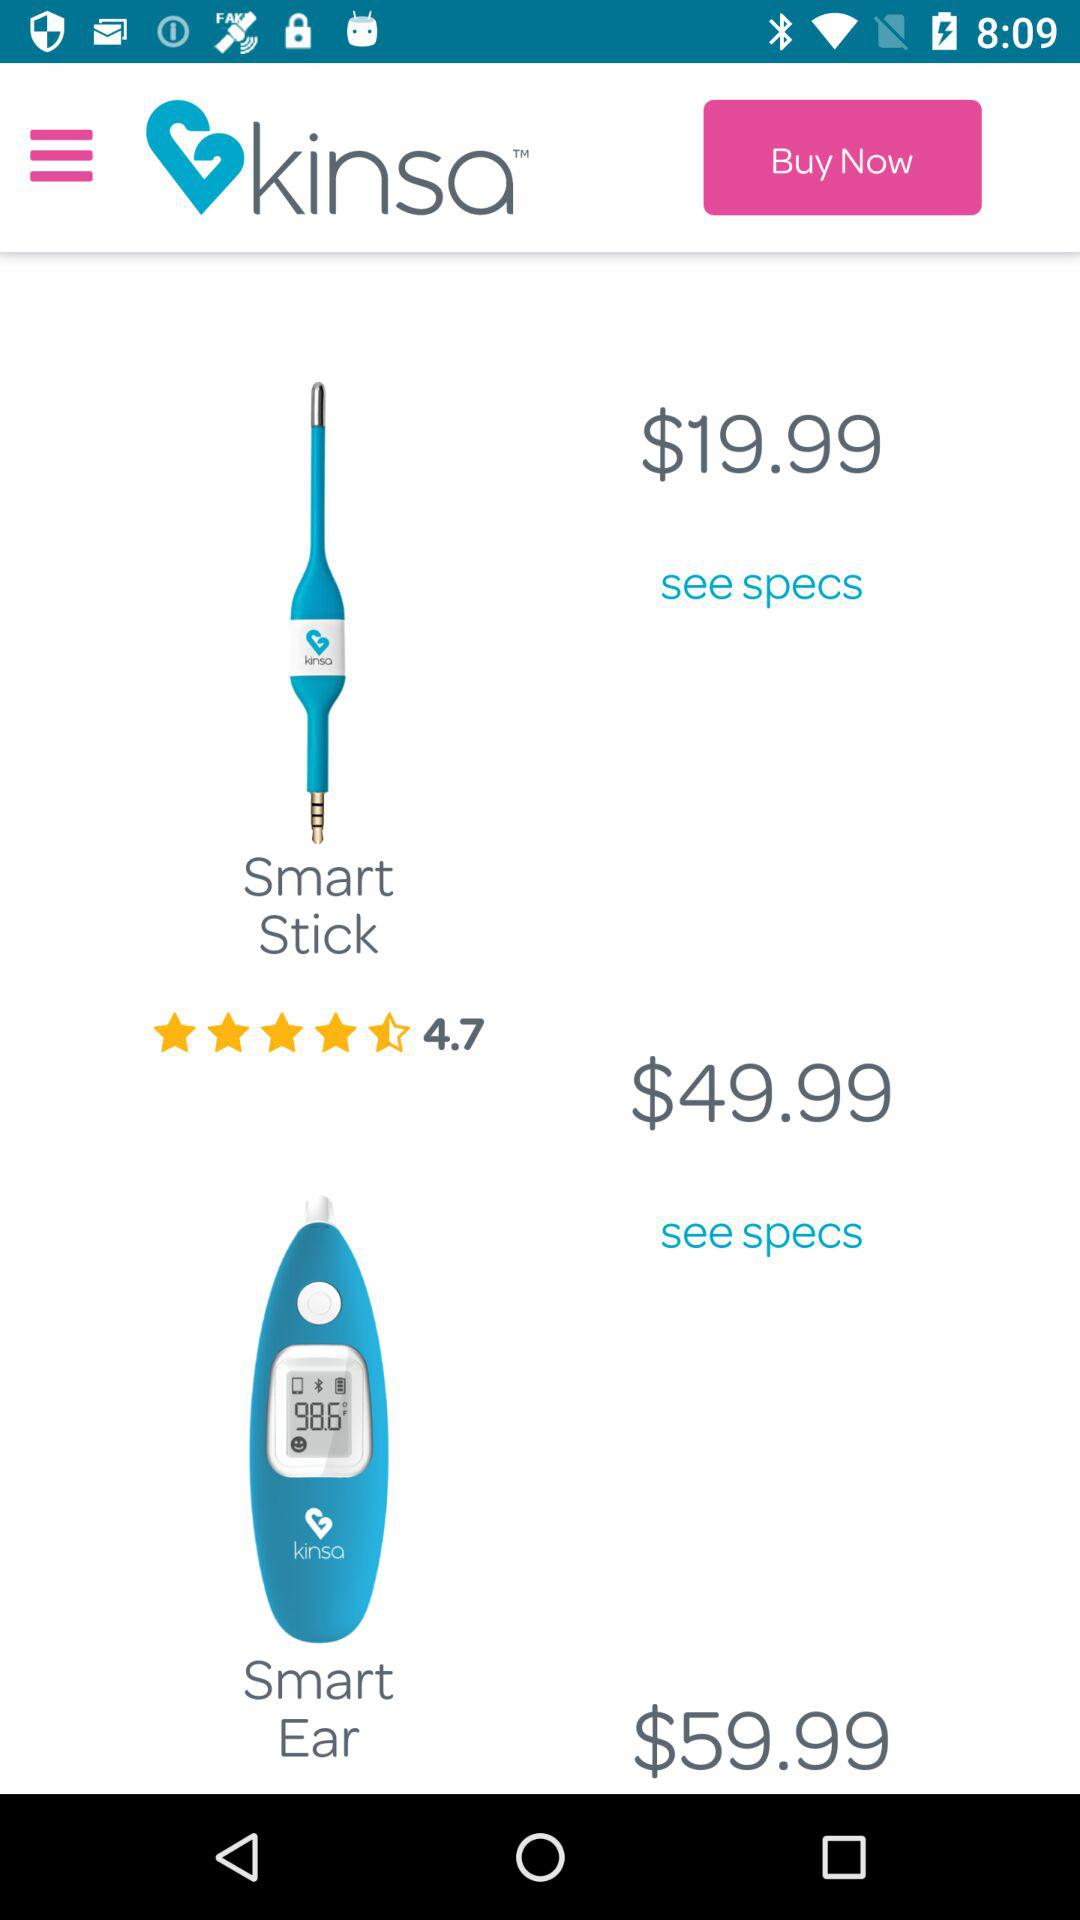What is the rating of the smart stick? The rating of the smart stick is 4.7. 